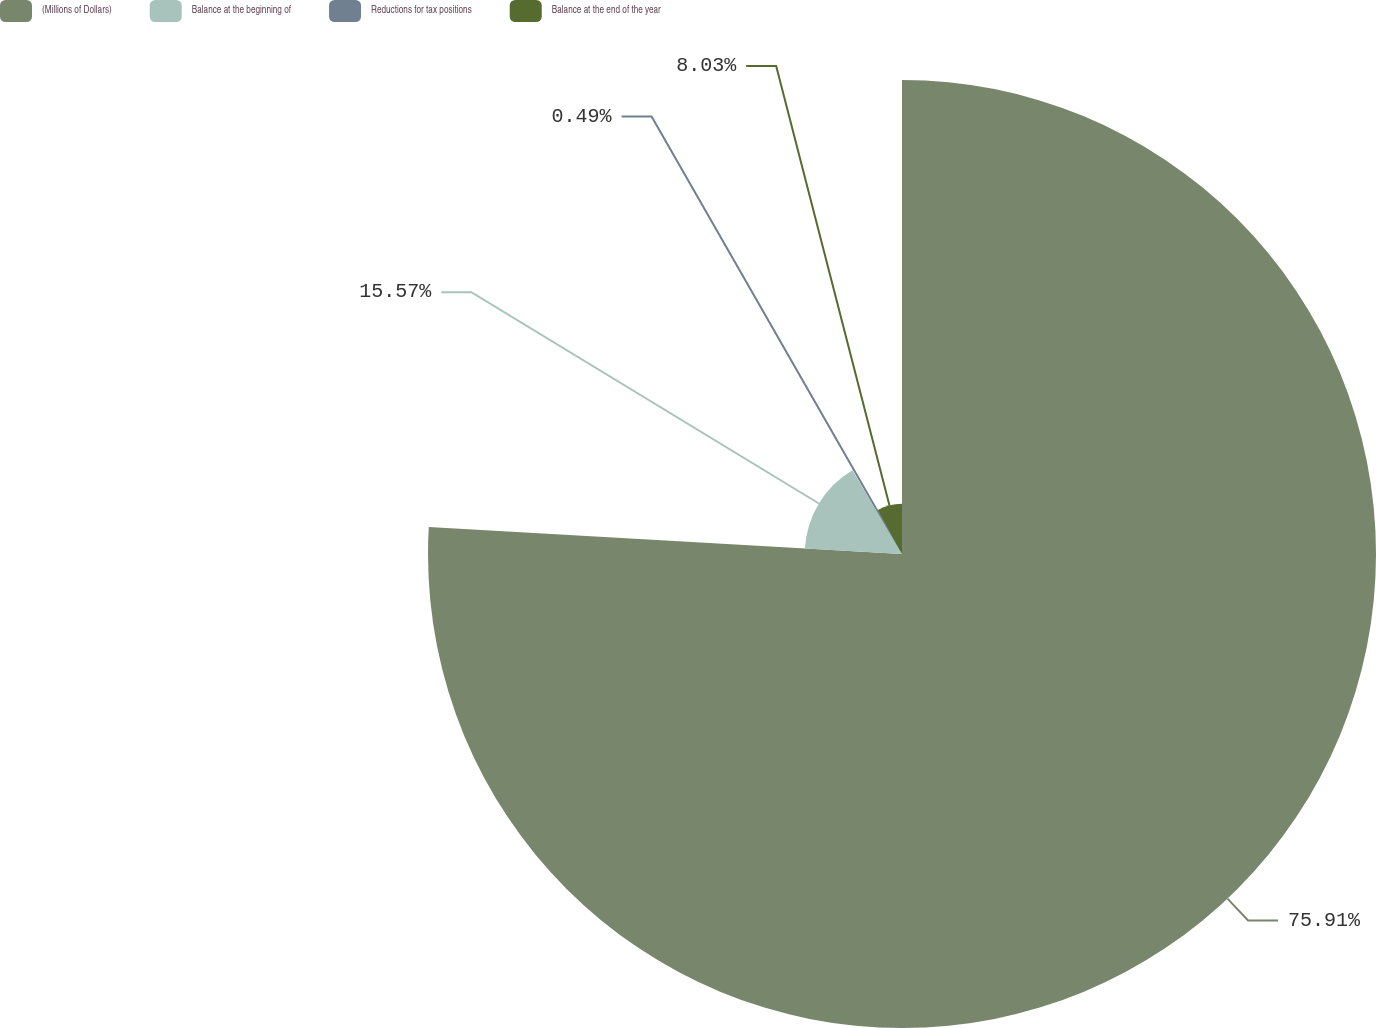Convert chart to OTSL. <chart><loc_0><loc_0><loc_500><loc_500><pie_chart><fcel>(Millions of Dollars)<fcel>Balance at the beginning of<fcel>Reductions for tax positions<fcel>Balance at the end of the year<nl><fcel>75.9%<fcel>15.57%<fcel>0.49%<fcel>8.03%<nl></chart> 